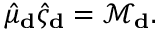<formula> <loc_0><loc_0><loc_500><loc_500>\hat { \mu } _ { d } \hat { \varsigma } _ { d } = \mathcal { M } _ { d } .</formula> 